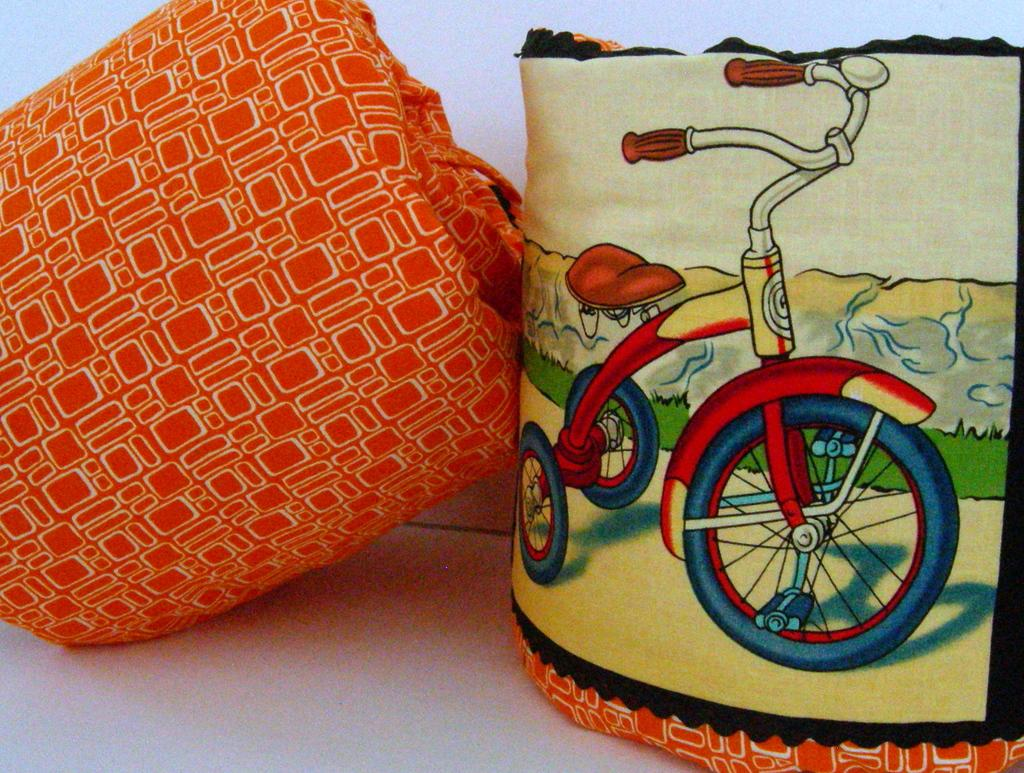What are the two orange-colored things in the image? There are two orange-colored things in the image, but without more information, we cannot determine what they are. What can be seen on the right side of the image? There is a depiction of a tricycle on the right side of the image. How much butter is present in the image? There is no butter present in the image. What act is being performed by the tricycle in the image? The tricycle is not performing an act; it is a static depiction in the image. 